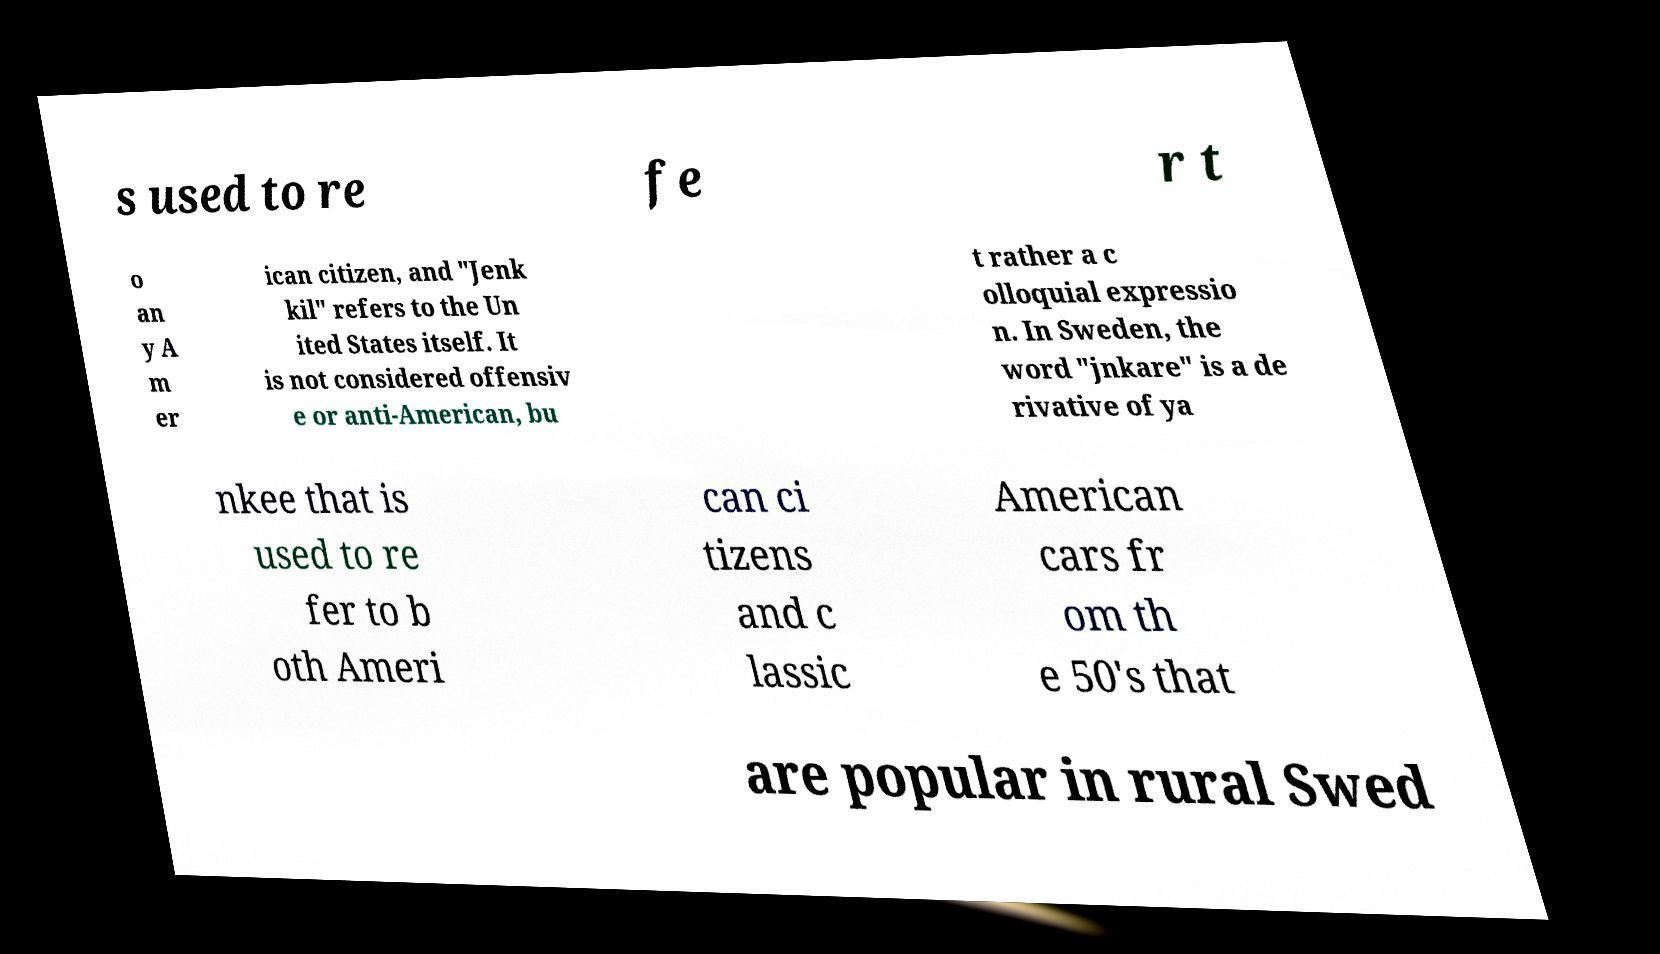Could you extract and type out the text from this image? s used to re fe r t o an y A m er ican citizen, and "Jenk kil" refers to the Un ited States itself. It is not considered offensiv e or anti-American, bu t rather a c olloquial expressio n. In Sweden, the word "jnkare" is a de rivative of ya nkee that is used to re fer to b oth Ameri can ci tizens and c lassic American cars fr om th e 50's that are popular in rural Swed 